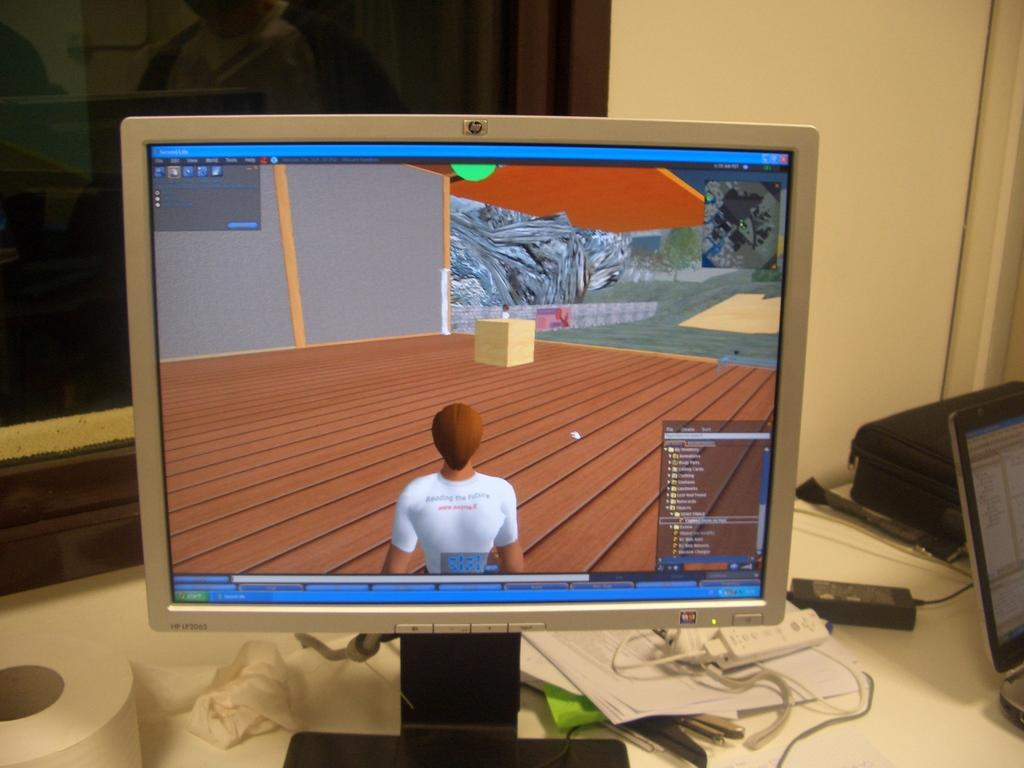<image>
Present a compact description of the photo's key features. An old HP monitor sits on a work area next to a newer laptop. 